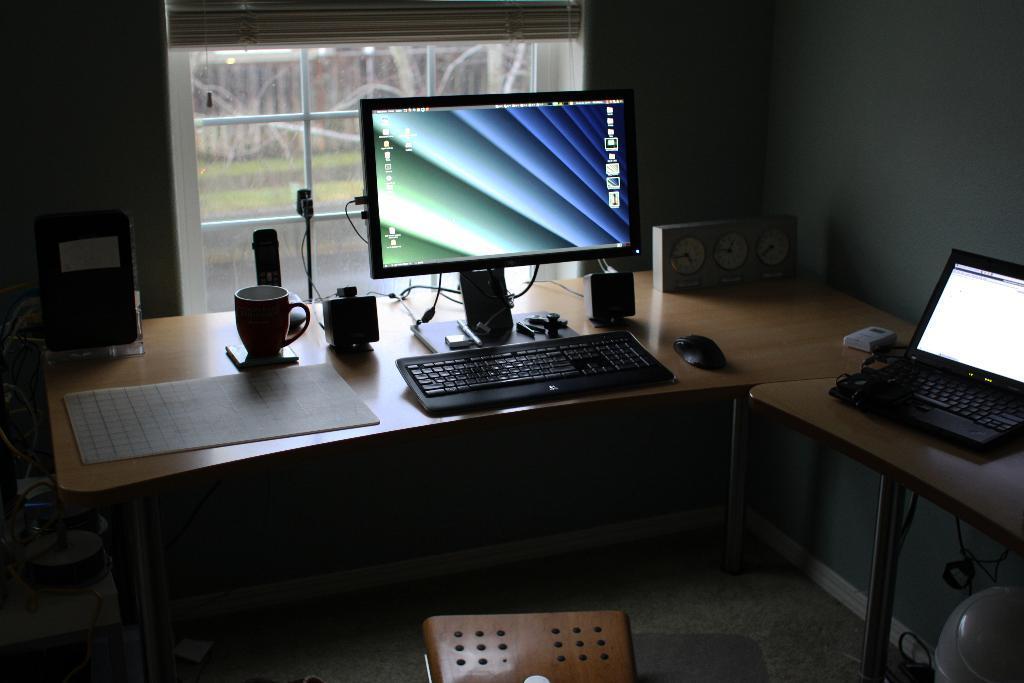How would you summarize this image in a sentence or two? In this picture we can see table and on table we have paper, cup, speakers, keyboard, monitor, mouse, laptop, remote and in background we can see window. 